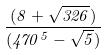<formula> <loc_0><loc_0><loc_500><loc_500>\frac { ( 8 + \sqrt { 3 2 6 } ) } { ( 4 7 0 ^ { 5 } - \sqrt { 5 } ) }</formula> 